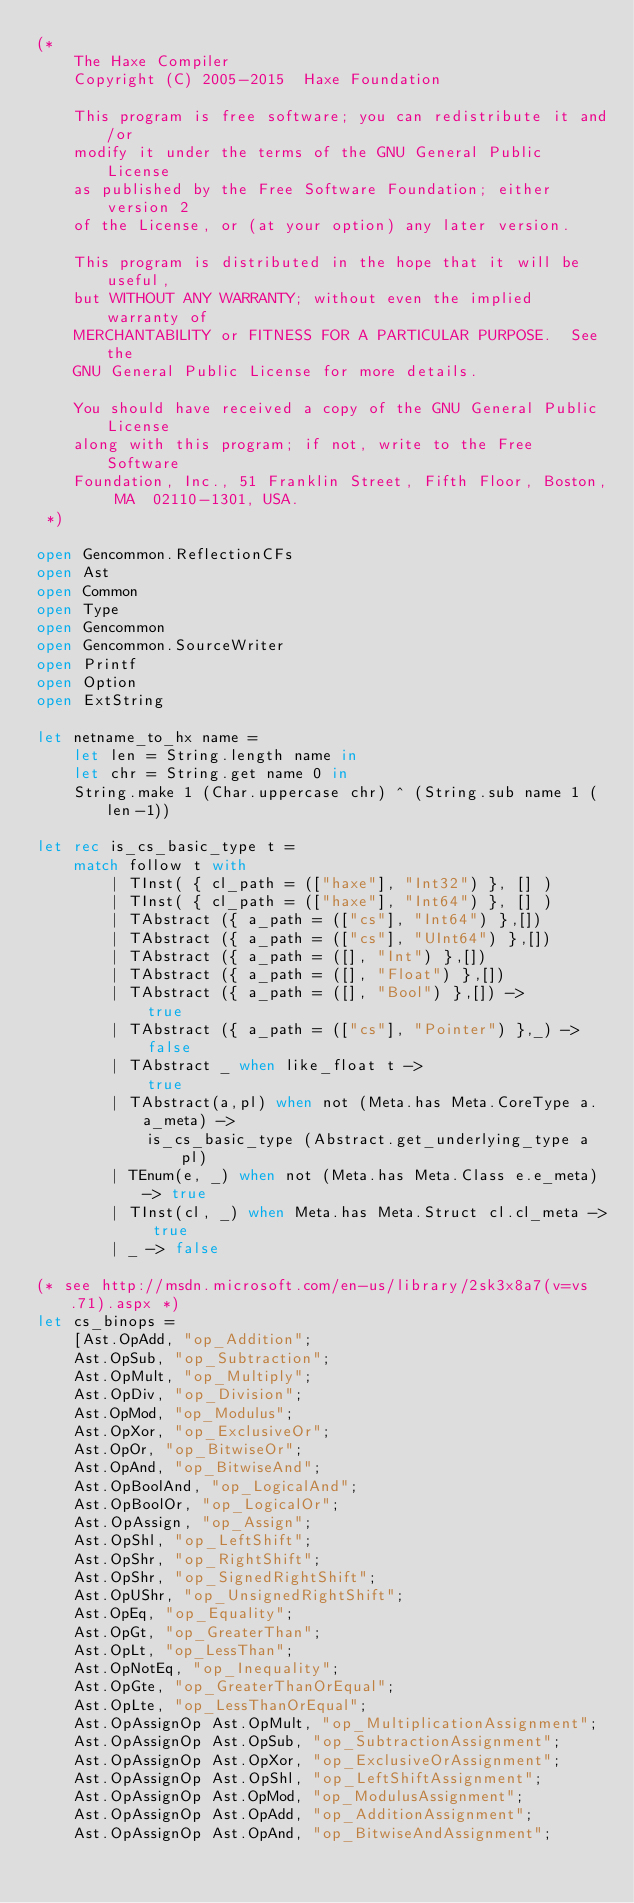Convert code to text. <code><loc_0><loc_0><loc_500><loc_500><_OCaml_>(*
	The Haxe Compiler
	Copyright (C) 2005-2015  Haxe Foundation

	This program is free software; you can redistribute it and/or
	modify it under the terms of the GNU General Public License
	as published by the Free Software Foundation; either version 2
	of the License, or (at your option) any later version.

	This program is distributed in the hope that it will be useful,
	but WITHOUT ANY WARRANTY; without even the implied warranty of
	MERCHANTABILITY or FITNESS FOR A PARTICULAR PURPOSE.  See the
	GNU General Public License for more details.

	You should have received a copy of the GNU General Public License
	along with this program; if not, write to the Free Software
	Foundation, Inc., 51 Franklin Street, Fifth Floor, Boston, MA  02110-1301, USA.
 *)

open Gencommon.ReflectionCFs
open Ast
open Common
open Type
open Gencommon
open Gencommon.SourceWriter
open Printf
open Option
open ExtString

let netname_to_hx name =
	let len = String.length name in
	let chr = String.get name 0 in
	String.make 1 (Char.uppercase chr) ^ (String.sub name 1 (len-1))

let rec is_cs_basic_type t =
	match follow t with
		| TInst( { cl_path = (["haxe"], "Int32") }, [] )
		| TInst( { cl_path = (["haxe"], "Int64") }, [] )
		| TAbstract ({ a_path = (["cs"], "Int64") },[])
		| TAbstract ({ a_path = (["cs"], "UInt64") },[])
		| TAbstract ({ a_path = ([], "Int") },[])
		| TAbstract ({ a_path = ([], "Float") },[])
		| TAbstract ({ a_path = ([], "Bool") },[]) ->
			true
		| TAbstract ({ a_path = (["cs"], "Pointer") },_) ->
			false
		| TAbstract _ when like_float t ->
			true
		| TAbstract(a,pl) when not (Meta.has Meta.CoreType a.a_meta) ->
			is_cs_basic_type (Abstract.get_underlying_type a pl)
		| TEnum(e, _) when not (Meta.has Meta.Class e.e_meta) -> true
		| TInst(cl, _) when Meta.has Meta.Struct cl.cl_meta -> true
		| _ -> false

(* see http://msdn.microsoft.com/en-us/library/2sk3x8a7(v=vs.71).aspx *)
let cs_binops =
	[Ast.OpAdd, "op_Addition";
	Ast.OpSub, "op_Subtraction";
	Ast.OpMult, "op_Multiply";
	Ast.OpDiv, "op_Division";
	Ast.OpMod, "op_Modulus";
	Ast.OpXor, "op_ExclusiveOr";
	Ast.OpOr, "op_BitwiseOr";
	Ast.OpAnd, "op_BitwiseAnd";
	Ast.OpBoolAnd, "op_LogicalAnd";
	Ast.OpBoolOr, "op_LogicalOr";
	Ast.OpAssign, "op_Assign";
	Ast.OpShl, "op_LeftShift";
	Ast.OpShr, "op_RightShift";
	Ast.OpShr, "op_SignedRightShift";
	Ast.OpUShr, "op_UnsignedRightShift";
	Ast.OpEq, "op_Equality";
	Ast.OpGt, "op_GreaterThan";
	Ast.OpLt, "op_LessThan";
	Ast.OpNotEq, "op_Inequality";
	Ast.OpGte, "op_GreaterThanOrEqual";
	Ast.OpLte, "op_LessThanOrEqual";
	Ast.OpAssignOp Ast.OpMult, "op_MultiplicationAssignment";
	Ast.OpAssignOp Ast.OpSub, "op_SubtractionAssignment";
	Ast.OpAssignOp Ast.OpXor, "op_ExclusiveOrAssignment";
	Ast.OpAssignOp Ast.OpShl, "op_LeftShiftAssignment";
	Ast.OpAssignOp Ast.OpMod, "op_ModulusAssignment";
	Ast.OpAssignOp Ast.OpAdd, "op_AdditionAssignment";
	Ast.OpAssignOp Ast.OpAnd, "op_BitwiseAndAssignment";</code> 